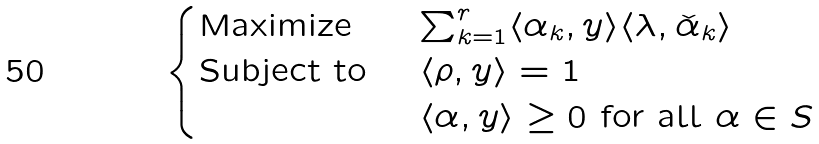<formula> <loc_0><loc_0><loc_500><loc_500>\begin{cases} \text {Maximize } & \sum _ { k = 1 } ^ { r } \langle \alpha _ { k } , y \rangle \langle \lambda , \check { \alpha } _ { k } \rangle \\ \text {Subject to } & \langle \rho , y \rangle = 1 \\ & \langle \alpha , y \rangle \geq 0 \text { for all } \alpha \in S \end{cases}</formula> 